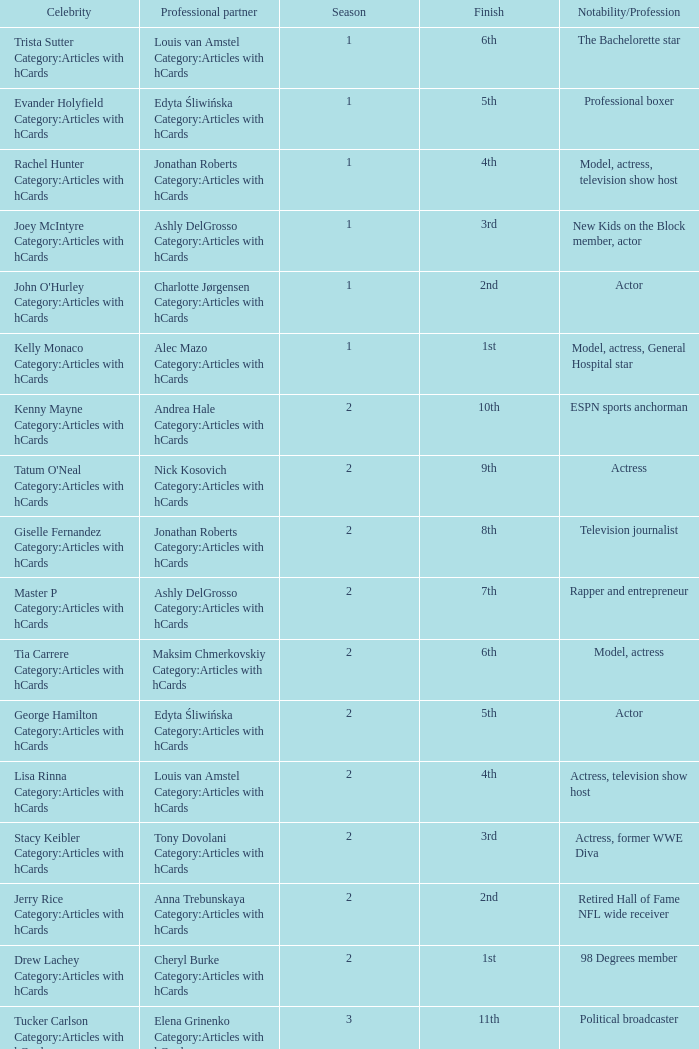What was the profession of the celebrity who was featured on season 15 and finished 7th place? Actress, comedian. Could you help me parse every detail presented in this table? {'header': ['Celebrity', 'Professional partner', 'Season', 'Finish', 'Notability/Profession'], 'rows': [['Trista Sutter Category:Articles with hCards', 'Louis van Amstel Category:Articles with hCards', '1', '6th', 'The Bachelorette star'], ['Evander Holyfield Category:Articles with hCards', 'Edyta Śliwińska Category:Articles with hCards', '1', '5th', 'Professional boxer'], ['Rachel Hunter Category:Articles with hCards', 'Jonathan Roberts Category:Articles with hCards', '1', '4th', 'Model, actress, television show host'], ['Joey McIntyre Category:Articles with hCards', 'Ashly DelGrosso Category:Articles with hCards', '1', '3rd', 'New Kids on the Block member, actor'], ["John O'Hurley Category:Articles with hCards", 'Charlotte Jørgensen Category:Articles with hCards', '1', '2nd', 'Actor'], ['Kelly Monaco Category:Articles with hCards', 'Alec Mazo Category:Articles with hCards', '1', '1st', 'Model, actress, General Hospital star'], ['Kenny Mayne Category:Articles with hCards', 'Andrea Hale Category:Articles with hCards', '2', '10th', 'ESPN sports anchorman'], ["Tatum O'Neal Category:Articles with hCards", 'Nick Kosovich Category:Articles with hCards', '2', '9th', 'Actress'], ['Giselle Fernandez Category:Articles with hCards', 'Jonathan Roberts Category:Articles with hCards', '2', '8th', 'Television journalist'], ['Master P Category:Articles with hCards', 'Ashly DelGrosso Category:Articles with hCards', '2', '7th', 'Rapper and entrepreneur'], ['Tia Carrere Category:Articles with hCards', 'Maksim Chmerkovskiy Category:Articles with hCards', '2', '6th', 'Model, actress'], ['George Hamilton Category:Articles with hCards', 'Edyta Śliwińska Category:Articles with hCards', '2', '5th', 'Actor'], ['Lisa Rinna Category:Articles with hCards', 'Louis van Amstel Category:Articles with hCards', '2', '4th', 'Actress, television show host'], ['Stacy Keibler Category:Articles with hCards', 'Tony Dovolani Category:Articles with hCards', '2', '3rd', 'Actress, former WWE Diva'], ['Jerry Rice Category:Articles with hCards', 'Anna Trebunskaya Category:Articles with hCards', '2', '2nd', 'Retired Hall of Fame NFL wide receiver'], ['Drew Lachey Category:Articles with hCards', 'Cheryl Burke Category:Articles with hCards', '2', '1st', '98 Degrees member'], ['Tucker Carlson Category:Articles with hCards', 'Elena Grinenko Category:Articles with hCards', '3', '11th', 'Political broadcaster'], ['Shanna Moakler Category:Articles with hCards', 'Jesse DeSoto Category:Articles with hCards', '3', '10th', 'Model, actress, former Miss USA'], ['Harry Hamlin Category:Articles with hCards', 'Ashly DelGrosso Category:Articles with hCards', '3', '9th', 'Actor'], ['Vivica A. Fox Category:Articles with hCards', 'Nick Kosovich Category:Articles with hCards', '3', '8th', 'Actress'], ['Willa Ford Category:Articles with hCards', 'Maksim Chmerkovskiy Category:Articles with hCards', '3', '7th', 'Singer, actress'], ['Sara Evans Category:Articles with hCards', 'Tony Dovolani Category:Articles with hCards', '3', '6th', 'Country music singer'], ['Jerry Springer Category:Articles with hCards', 'Kym Johnson Category:Articles with hCards', '3', '5th', 'Television personality , talk show host'], ['Monique Coleman Category:Articles with hCards', 'Louis van Amstel Category:Articles with hCards', '3', '4th', 'Actress'], ['Joey Lawrence Category:Articles with hCards', 'Edyta Śliwińska Category:Articles with hCards', '3', '3rd', 'Actor, singer'], ['Mario Lopez Category:Articles with hCards', 'Karina Smirnoff Category:Articles with hCards', '3', '2nd', 'Actor, television show host'], ['Emmitt Smith Category:Articles with hCards', 'Cheryl Burke Category:Articles with hCards', '3', '1st', 'Retired Hall of Fame NFL running back'], ['Paulina Porizkova Category:Articles with hCards', 'Alec Mazo Category:Articles with hCards', '4', '11th', 'Supermodel , actress'], ['Shandi Finnessey Category:Articles with hCards', 'Brian Fortuna Category:Articles with hCards', '4', '10th', 'Miss USA 2004, Lingo co-host'], ['Leeza Gibbons Category:Articles with hCards', 'Tony Dovolani Category:Articles with hCards', '4', '9th', 'Television show host'], ['Clyde Drexler Category:Articles with hCards', 'Elena Grinenko Category:Articles with hCards', '4', '8th', 'Former NBA shooting guard'], ['Heather Mills Category:Articles with hCards', 'Jonathan Roberts Category:Articles with hCards', '4', '7th', 'Charity campaigner'], ['John Ratzenberger Category:Articles with hCards', 'Edyta Śliwińska Category:Articles with hCards', '4', '6th', 'Actor, television show host'], ['Billy Ray Cyrus Category:Articles with hCards', 'Karina Smirnoff Category:Articles with hCards', '4', '5th', 'Country music singer, actor'], ['Ian Ziering Category:Articles with hCards', 'Cheryl Burke Category:Articles with hCards', '4', '4th', 'Actor'], ['Laila Ali Category:Articles with hCards', 'Maksim Chmerkovskiy Category:Articles with hCards', '4', '3rd', 'Boxer , daughter of Muhammad Ali'], ['Joey Fatone Category:Articles with hCards', 'Kym Johnson Category:Articles with hCards', '4', '2nd', "'N Sync member, actor"], ['Apolo Anton Ohno Category:Articles with hCards', 'Julianne Hough Category:Articles with hCards', '4', '1st', 'Short track speed skating Olympian'], ['Josie Maran Category:Articles with hCards', 'Alec Mazo Category:Articles with hCards', '5', '12th', 'Actress, model'], ['Albert Reed Category:Articles with hCards', 'Anna Trebunskaya Category:Articles with hCards', '5', '11th', 'Model'], ['Wayne Newton Category:Articles with hCards', 'Cheryl Burke Category:Articles with hCards', '5', '10th', 'Las Vegas , Nevada entertainer'], ['Floyd Mayweather Category:Articles with hCards', 'Karina Smirnoff Category:Articles with hCards', '5', '9th', 'Professional boxer'], ['Mark Cuban Category:Articles with hCards', 'Kym Johnson Category:Articles with hCards', '5', '8th', 'Entrepreneur'], ['Sabrina Bryan Category:Articles with hCards', 'Mark Ballas Category:Articles with hCards', '5', '7th', 'The Cheetah Girls member'], ['Jane Seymour Category:Articles with hCards', 'Tony Dovolani Category:Articles with hCards', '5', '6th', 'Actress'], ['Cameron Mathison Category:Articles with hCards', 'Edyta Śliwińska Category:Articles with hCards', '5', '5th', 'Actor, All My Children star'], ['Jennie Garth Category:Articles with hCards', 'Derek Hough Category:Articles with hCards', '5', '4th', 'Actress'], ['Marie Osmond Category:Articles with hCards', 'Jonathan Roberts Category:Articles with hCards', '5', '3rd', 'Singer, member of The Osmonds'], ['Mel B Category:Articles with hCards', 'Maksim Chmerkovskiy Category:Articles with hCards', '5', '2nd', 'Spice Girls member'], ['Hélio Castroneves Category:Articles with hCards', 'Julianne Hough Category:Articles with hCards', '5', '1st', 'Indy 500 champion racer'], ['Penn Jillette Category:Articles with hCards', 'Kym Johnson Category:Articles with hCards', '6', '12th', 'Magician'], ['Monica Seles Category:Articles with hCards', 'Jonathan Roberts Category:Articles with hCards', '6', '11th', 'Grand Slam tennis champion'], ['Steve Guttenberg Category:Articles with hCards', 'Anna Trebunskaya Category:Articles with hCards', '6', '10th', 'Actor'], ['Adam Carolla Category:Articles with hCards', 'Julianne Hough Category:Articles with hCards', '6', '9th', 'Radio/television show host, comedian'], ['Priscilla Presley Category:Articles with hCards', 'Louis van Amstel Category:Articles with hCards', '6', '8th', 'Actress, ex-wife of Elvis Presley'], ['Marlee Matlin Category:Articles with hCards', 'Fabian Sanchez Category:Articles with hCards', '6', '7th', 'Actress'], ['Shannon Elizabeth Category:Articles with hCards', 'Derek Hough Category:Articles with hCards', '6', '6th', 'Actress, model'], ['Mario Category:Articles with hCards', 'Karina Smirnoff Category:Articles with hCards', '6', '5th', 'R&B singer'], ['Jason Taylor Category:Articles with hCards', 'Edyta Śliwińska Category:Articles with hCards', '6', '2nd', 'Retired NFL linebacker'], ['Kristi Yamaguchi Category:Articles with hCards', 'Mark Ballas Category:Articles with hCards', '6', '1st', 'Olympic champion figure skater'], ['Jeffrey Ross Category:Articles with hCards', 'Edyta Śliwińska Category:Articles with hCards', '7', '13th', 'Comedian'], ['Ted McGinley Category:Articles with hCards', 'Inna Brayer Category:Articles with hCards', '7', '12th', 'Actor'], ['Kim Kardashian Category:Articles with hCards', 'Mark Ballas Category:Articles with hCards', '7', '11th', 'Reality television star, model'], ['Misty May-Treanor Category:Articles with hCards', 'Maksim Chmerkovskiy Category:Articles with hCards', '7', '10th', 'Olympic champion beach volleyball player'], ['Rocco DiSpirito Category:Articles with hCards', 'Karina Smirnoff Category:Articles with hCards', '7', '9th', 'Celebrity chef'], ['Toni Braxton Category:Articles with hCards', 'Alec Mazo Category:Articles with hCards', '7', '8th', 'Singer'], ['Cloris Leachman Category:Articles with hCards', 'Corky Ballas Category:Articles with hCards', '7', '7th', 'Actress'], ['Susan Lucci Category:Articles with hCards', 'Tony Dovolani Category:Articles with hCards', '7', '6th', 'Actress, All My Children star'], ['Maurice Greene Category:Articles with hCards', 'Cheryl Burke Category:Articles with hCards', '7', '5th', 'Olympic champion sprinter'], ['Cody Linley Category:Articles with hCards', 'Julianne Hough Category:Articles with hCards', '7', '4th', 'Actor, Disney Channel star'], ['Lance Bass Category:Articles with hCards', 'Lacey Schwimmer Category:Articles with hCards', '7', '3rd', "Former 'N Sync member"], ['Warren Sapp Category:Articles with hCards', 'Kym Johnson Category:Articles with hCards', '7', '2nd', 'Retired NFL defensive tackle'], ['Brooke Burke Category:Articles with hCards', 'Derek Hough Category:Articles with hCards', '7', '1st', 'Model, television show host'], ['Belinda Carlisle Category:Articles with hCards', 'Jonathan Roberts Category:Articles with hCards', '8', '13th', "The Go-Go's member"], ['Denise Richards Category:Articles with hCards', 'Maksim Chmerkovskiy Category:Articles with hCards', '8', '12th', 'Actress'], ['Holly Madison Category:Articles with hCards', 'Dmitry Chaplin Category:Articles with hCards', '8', '11th', 'Reality television star, Playboy model'], ['Steve Wozniak Category:Articles with hCards', 'Karina Smirnoff Category:Articles with hCards', '8', '10th', 'Apple Inc. co-founder'], ['David Alan Grier Category:Articles with hCards', 'Kym Johnson Category:Articles with hCards', '8', '9th', 'Actor, comedian'], ['Steve-O', 'Lacey Schwimmer Category:Articles with hCards', '8', '8th', 'Jackass star'], ['Lawrence Taylor Category:Articles with hCards', 'Edyta Śliwińska Category:Articles with hCards', '8', '7th', 'Retired Hall of Fame NFL linebacker'], ['Chuck Wicks Category:Articles with hCards', 'Julianne Hough Category:Articles with hCards', '8', '6th', 'Country music singer'], ["Lil' Kim Category:Articles with hCards", 'Derek Hough Category:Articles with hCards', '8', '5th', 'Rapper'], ['Ty Murray Category:Articles with hCards', 'Chelsie Hightower Category:Articles with hCards', '8', '4th', 'Rodeo champion'], ['Melissa Rycroft Category:Articles with hCards', 'Tony Dovolani Category:Articles with hCards', '8', '3rd', 'The Bachelor participant'], ['Gilles Marini Category:Articles with hCards', 'Cheryl Burke Category:Articles with hCards', '8', '2nd', 'Actor'], ['Shawn Johnson Category:Articles with hCards', 'Mark Ballas Category:Articles with hCards', '8', '1st', 'Olympic champion gymnast'], ['Ashley Hamilton Category:Articles with hCards', 'Edyta Śliwińska Category:Articles with hCards', '9', '16th', 'Actor, comedian'], ['Macy Gray Category:Articles with hCards', 'Jonathan Roberts Category:Articles with hCards', '9', '15th', 'Singer'], ['Kathy Ireland Category:Articles with hCards', 'Tony Dovolani Category:Articles with hCards', '9', '14th', 'Supermodel , entrepreneur'], ['Tom DeLay Category:Articles with hCards', 'Cheryl Burke Category:Articles with hCards', '9', '13th', 'Former U.S. House Majority Leader'], ['Debi Mazar Category:Articles with hCards', 'Maksim Chmerkovskiy Category:Articles with hCards', '9', '12th', 'Actress'], ['Chuck Liddell Category:Articles with hCards', 'Anna Trebunskaya Category:Articles with hCards', '9', '11th', 'UFC champion'], ['Natalie Coughlin Category:Articles with hCards', 'Alec Mazo Category:Articles with hCards', '9', '10th', 'Olympic champion swimmer'], ['Melissa Joan Hart Category:Articles with hCards', 'Mark Ballas Category:Articles with hCards', '9', '9th', 'Actress'], ['Louie Vito Category:Articles with hCards', 'Chelsie Hightower Category:Articles with hCards', '9', '8th', 'Professional er snowboard'], ['Michael Irvin Category:Articles with hCards', 'Anna Demidova Category:Articles with hCards', '9', '7th', 'Retired Hall of Fame NFL wide receiver'], ['Mark Dacascos Category:Articles with hCards', 'Lacey Schwimmer Category:Articles with hCards', '9', '6th', 'Iron Chef America host, martial artist'], ['Aaron Carter Category:Articles with hCards', 'Karina Smirnoff Category:Articles with hCards', '9', '5th', 'Singer'], ['Joanna Krupa Category:Articles with hCards', 'Derek Hough Category:Articles with hCards', '9', '4th', 'Supermodel'], ['Kelly Osbourne Category:Articles with hCards', 'Louis van Amstel Category:Articles with hCards', '9', '3rd', 'Singer, reality television star'], ['Mýa', 'Dmitry Chaplin Category:Articles with hCards', '9', '2nd', 'Singer'], ['Donny Osmond Category:Articles with hCards', 'Kym Johnson Category:Articles with hCards', '9', '1st', 'Singer, member of The Osmonds'], ['Shannen Doherty Category:Articles with hCards', 'Mark Ballas Category:Articles with hCards', '10', '11th', 'Actress'], ['Aiden Turner Category:Articles with hCards', 'Edyta Śliwińska Category:Articles with hCards', '10', '9th', 'Actor, All My Children star'], ['Kate Gosselin Category:Articles with hCards', 'Tony Dovolani Category:Articles with hCards', '10', '8th', 'Reality television star'], ['Jake Pavelka Category:Articles with hCards', 'Chelsie Hightower Category:Articles with hCards', '10', '7th', 'The Bachelor star'], ['Pamela Anderson Category:Articles with hCards', 'Damian Whitewood Category:Articles with hCards', '10', '6th', 'Actress, former Playboy Playmate'], ['Niecy Nash Category:Articles with hCards', 'Louis van Amstel Category:Articles with hCards', '10', '5th', 'Actress, comedian'], ['Chad Ochocinco Category:Articles with hCards', 'Cheryl Burke Category:Articles with hCards', '10', '4th', 'NFL wide receiver'], ['Erin Andrews Category:Articles with hCards', 'Maksim Chmerkovskiy Category:Articles with hCards', '10', '3rd', 'ESPN sportscaster'], ['Evan Lysacek Category:Articles with hCards', 'Anna Trebunskaya Category:Articles with hCards', '10', '2nd', 'Olympic gold medal figure skater'], ['Nicole Scherzinger Category:Articles with hCards', 'Derek Hough Category:Articles with hCards', '10', '1st', 'Singer, member of the Pussycat Dolls'], ['David Hasselhoff Category:Articles with hCards', 'Kym Johnson Category:Articles with hCards', '11', '12th', 'Actor'], ['Michael Bolton Category:Articles with hCards', 'Chelsie Hightower Category:Articles with hCards', '11', '11th', 'Grammy Award -winning singer'], ['Margaret Cho Category:Articles with hCards', 'Louis van Amstel Category:Articles with hCards', '11', '10th', 'Comedian , actress'], ['Florence Henderson Category:Articles with hCards', 'Corky Ballas Category:Articles with hCards', '11', '8th', 'Actress ( The Brady Bunch )'], ['Audrina Patridge Category:Articles with hCards', 'Tony Dovolani Category:Articles with hCards', '11', '7th', 'The Hills star, model'], ['Rick Fox Category:Articles with hCards', 'Cheryl Burke Category:Articles with hCards', '11', '6th', 'Retired NBA champion'], ['Kurt Warner Category:Articles with hCards', 'Anna Trebunskaya Category:Articles with hCards', '11', '5th', 'Retired NFL quarterback'], ['Brandy Category:Articles with hCards', 'Maksim Chmerkovskiy Category:Articles with hCards', '11', '4th', 'Grammy Award -winning singer, actress'], ['Bristol Palin Category:Articles with hCards', 'Mark Ballas Category:Articles with hCards', '11', '3rd', 'Teen activist, daughter of Sarah Palin'], ['Kyle Massey Category:Articles with hCards', 'Lacey Schwimmer Category:Articles with hCards', '11', '2nd', 'Disney Channel star'], ['Jennifer Grey Category:Articles with hCards', 'Derek Hough Category:Articles with hCards', '11', '1st', 'Actress'], ['Mike Catherwood Category:Articles with hCards', 'Lacey Schwimmer Category:Articles with hCards', '12', '11th', 'Radio talk show host'], ['Wendy Williams Category:Articles with hCards', 'Tony Dovolani Category:Articles with hCards', '12', '10th', 'Media personality , talk show host'], ['Sugar Ray Leonard Category:Articles with hCards', 'Anna Trebunskaya Category:Articles with hCards', '12', '9th', 'Retired professional boxer'], ['Petra Nemcova Category:Articles with hCards', 'Dmitry Chaplin Category:Articles with hCards', '12', '8th', 'Supermodel'], ['Chris Jericho Category:Articles with hCards', 'Cheryl Burke Category:Articles with hCards', '12', '7th', 'WWE wrestler'], ['Kendra Wilkinson Category:Articles with hCards', 'Louis van Amstel Category:Articles with hCards', '12', '6th', 'Playboy model , reality television star'], ['Romeo Category:Articles with hCards', 'Chelsie Hightower Category:Articles with hCards', '12', '5th', 'Rapper , actor'], ['Ralph Macchio Category:Articles with hCards', 'Karina Smirnoff Category:Articles with hCards', '12', '4th', 'Actor'], ['Chelsea Kane Category:Articles with hCards', 'Mark Ballas Category:Articles with hCards', '12', '3rd', 'Disney Channel star'], ['Kirstie Alley Category:Articles with hCards', 'Maksim Chmerkovskiy Category:Articles with hCards', '12', '2nd', 'Actress, comedian'], ['Hines Ward Category:Articles with hCards', 'Kym Johnson Category:Articles with hCards', '12', '1st', 'NFL wide receiver'], ['Metta World Peace Category:Articles with hCards', 'Peta Murgatroyd Category:Articles with hCards', '13', '12th', 'NBA small forward'], ['Kristin Cavallari Category:Articles with hCards', 'Mark Ballas Category:Articles with hCards', '13', '10th', 'The Hills star, actress'], ['Chynna Phillips Category:Articles with hCards', 'Tony Dovolani Category:Articles with hCards', '13', '9th', 'Singer, actress'], ['Carson Kressley Category:Articles with hCards', 'Anna Trebunskaya Category:Articles with hCards', '13', '8th', 'Fashion entrepreneur, fashion designer'], ['Chaz Bono Category:Articles with hCards', 'Lacey Schwimmer Category:Articles with hCards', '13', '7th', 'Transgender activist'], ['David Arquette Category:Articles with hCards', 'Kym Johnson Category:Articles with hCards', '13', '6th', 'Actor, movie producer'], ['Nancy Grace Category:Articles with hCards', 'Tristan MacManus Category:Articles with hCards', '13', '5th', 'HLN hostess'], ['Hope Solo Category:Articles with hCards', 'Maksim Chmerkovskiy Category:Articles with hCards', '13', '4th', 'American Soccer goalkeeper'], ['Ricki Lake Category:Articles with hCards', 'Derek Hough Category:Articles with hCards', '13', '3rd', 'Actress, talk show host'], ['Rob Kardashian Category:Articles with hCards', 'Cheryl Burke Category:Articles with hCards', '13', '2nd', 'Reality television star'], ['J.R. Martinez Category:Articles with hCards', 'Karina Smirnoff Category:Articles with hCards', '13', '1st', 'Actor, retired US Soldier'], ['Martina Navratilova Category:Articles with hCards', 'Tony Dovolani Category:Articles with hCards', '14', '12th', 'Retired Czech American tennis player'], ['Jack Wagner Category:Articles with hCards', 'Anna Trebunskaya Category:Articles with hCards', '14', '11th', 'Singer, soap star'], ['Gavin DeGraw Category:Articles with hCards', 'Karina Smirnoff Category:Articles with hCards', '14', '9th', 'Singer'], ['Gladys Knight Category:Articles with hCards', 'Tristan MacManus Category:Articles with hCards', '14', '8th', 'Grammy Award -winning singer'], ['Jaleel White Category:Articles with hCards', 'Kym Johnson Category:Articles with hCards', '14', '7th', 'Actor'], ['Roshon Fegan Category:Articles with hCards', 'Chelsie Hightower Category:Articles with hCards', '14', '6th', 'Disney Channel star'], ['Melissa Gilbert Category:Articles with hCards', 'Maksim Chmerkovskiy Category:Articles with hCards', '14', '5th', 'Actress'], ['Maria Menounos Category:Articles with hCards', 'Derek Hough Category:Articles with hCards', '14', '4th', 'Actress, model'], ['William Levy Category:Articles with hCards', 'Cheryl Burke Category:Articles with hCards', '14', '3rd', 'Actor'], ['Katherine Jenkins Category:Articles with hCards', 'Mark Ballas Category:Articles with hCards', '14', '2nd', 'Classical singer'], ['Donald Driver Category:Articles with hCards', 'Peta Murgatroyd Category:Articles with hCards', '14', '1st', 'NFL wide receiver & author'], ['Pamela Anderson Category:Articles with hCards', 'Tristan MacManus Category:Articles with hCards', '15', '13th', 'Actress, former Playboy Playmate'], ['Joey Fatone Category:Articles with hCards', 'Kym Johnson Category:Articles with hCards', '15', '12th', "'N Sync member, actor"], ['Drew Lachey Category:Articles with hCards', 'Anna Trebunskaya Category:Articles with hCards', '15', '11th', '98 Degrees member'], ['Hélio Castroneves Category:Articles with hCards', 'Chelsie Hightower Category:Articles with hCards', '15', '10th', 'Indy 500 champion racer'], ['Bristol Palin Category:Articles with hCards', 'Mark Ballas Category:Articles with hCards', '15', '9th', 'Teen activist, daughter of Sarah Palin'], ['Sabrina Bryan Category:Articles with hCards', 'Louis van Amstel Category:Articles with hCards', '15', '8th', 'The Cheetah Girls member'], ['Kirstie Alley Category:Articles with hCards', 'Maksim Chmerkovskiy Category:Articles with hCards', '15', '7th', 'Actress, comedian'], ['Gilles Marini Category:Articles with hCards', 'Peta Murgatroyd Category:Articles with hCards', '15', '6th', 'Actor'], ['Apolo Anton Ohno Category:Articles with hCards', 'Karina Smirnoff Category:Articles with hCards', '15', '5th', 'Short track speed skating Olympian'], ['Emmitt Smith Category:Articles with hCards', 'Cheryl Burke Category:Articles with hCards', '15', '4th', 'Retired Hall of Fame NFL running back'], ['Shawn Johnson Category:Articles with hCards', 'Derek Hough Category:Articles with hCards', '15', '2nd', 'Olympic champion gymnast'], ['Melissa Rycroft Category:Articles with hCards', 'Tony Dovolani Category:Articles with hCards', '15', '1st', 'Television personality and host'], ['Dorothy Hamill Category:Articles with hCards', 'Tristan MacManus Category:Articles with hCards', '16', '12th', 'Olympic champion figure skater'], ['Wynonna Judd Category:Articles with hCards', 'Tony Dovolani Category:Articles with hCards', '16', '11th', 'Country music singer'], ['Lisa Vanderpump Category:Articles with hCards', 'Gleb Savchenko Category:Articles with hCards', '16', '10th', 'The Real Housewives of Beverly Hills star'], ['D.L. Hughley Category:Articles with hCards', 'Cheryl Burke Category:Articles with hCards', '16', '9th', 'Actor, comedian'], ['Victor Ortiz Category:Articles with hCards', 'Lindsay Arnold Category:Articles with hCards', '16', '8th', 'Professional boxer'], ['Andy Dick Category:Articles with hCards', 'Sharna Burgess Category:Articles with hCards', '16', '7th', 'Actor, comedian'], ['Sean Lowe Category:Articles with hCards', 'Peta Murgatroyd Category:Articles with hCards', '16', '6th', 'The Bachelor star'], ['Ingo Rademacher Category:Articles with hCards', 'Kym Johnson Category:Articles with hCards', '16', '5th', 'Actor, General Hospital star'], ['Alexandra Raisman Category:Articles with hCards', 'Mark Ballas Category:Articles with hCards', '16', '4th', 'Olympic champion gymnast'], ['Jacoby Jones Category:Articles with hCards', 'Karina Smirnoff Category:Articles with hCards', '16', '3rd', 'NFL wide receiver'], ['Kellie Pickler Category:Articles with hCards', 'Derek Hough Category:Articles with hCards', '16', '1st', 'Country music singer, television personality'], ['Keyshawn Johnson Category:Articles with hCards', 'Sharna Burgess Category:Articles with hCards', '17', '12th', 'Retired NFL wide receiver'], ['Bill Nye Category:Articles with hCards', 'Tyne Stecklein Category:Articles with hCards', '17', '11th', 'Science educator, television personality'], ['Valerie Harper Category:Articles with hCards', 'Tristan MacManus Category:Articles with hCards', '17', '10th', 'Actress'], ['Christina Milian Category:Articles with hCards', 'Mark Ballas Category:Articles with hCards', '17', '9th', 'Singer, The Voice hostess'], ['Corbin Bleu Category:Articles with hCards', 'Karina Smirnoff Category:Articles with hCards', '17', 'TBA', 'Actor, Disney Channel star'], ['Brant Daugherty Category:Articles with hCards', 'Peta Murgatroyd Category:Articles with hCards', '17', 'TBA', 'Actor'], ['Bill Engvall Category:Articles with hCards', 'Emma Slater Category:Articles with hCards', '17', 'TBA', 'Actor, comedian'], ['Jack Osbourne Category:Articles with hCards', 'Cheryl Burke Category:Articles with hCards', '17', 'TBA', 'Reality television star, media personality'], ['Leah Remini Category:Articles with hCards', 'Tony Dovolani Category:Articles with hCards', '17', 'TBA', 'Actress, former The Talk co-host']]} 